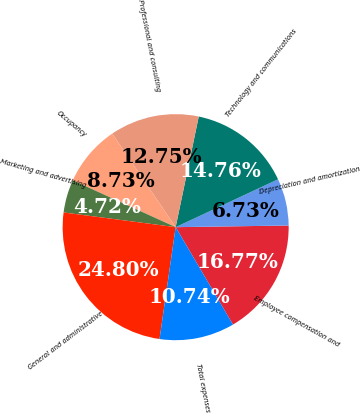<chart> <loc_0><loc_0><loc_500><loc_500><pie_chart><fcel>Employee compensation and<fcel>Depreciation and amortization<fcel>Technology and communications<fcel>Professional and consulting<fcel>Occupancy<fcel>Marketing and advertising<fcel>General and administrative<fcel>Total expenses<nl><fcel>16.77%<fcel>6.73%<fcel>14.76%<fcel>12.75%<fcel>8.73%<fcel>4.72%<fcel>24.8%<fcel>10.74%<nl></chart> 